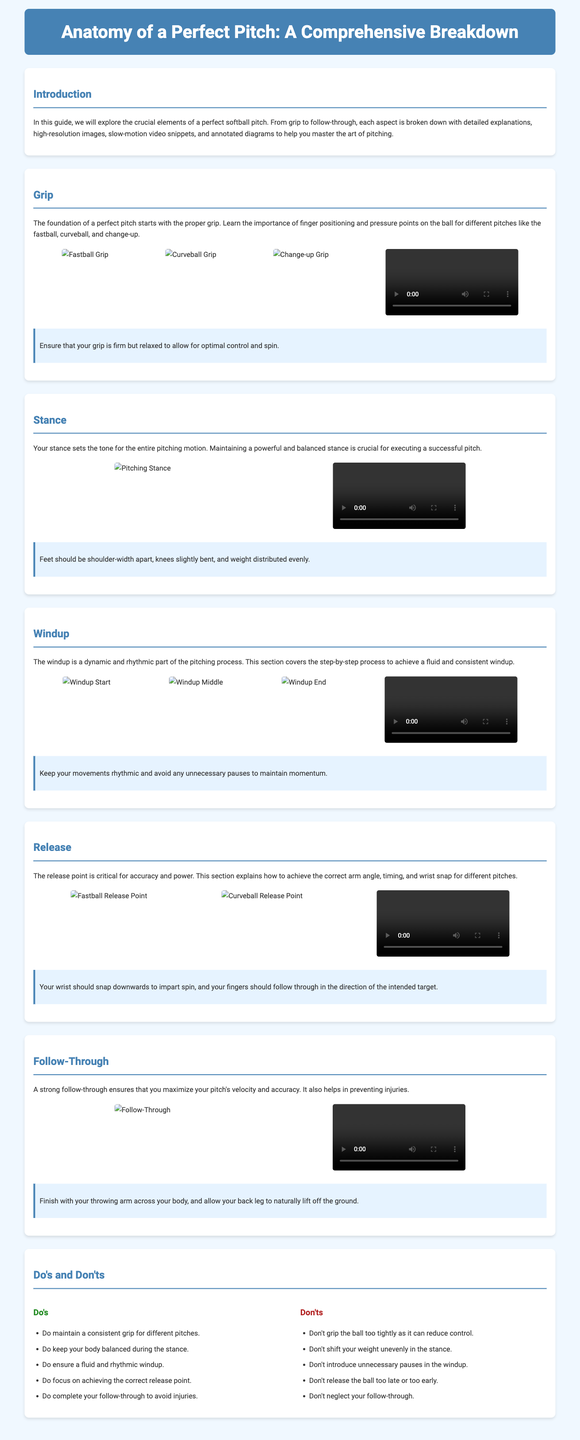What is the title of the guide? The title is stated in the header of the document and introduces the subject of the content.
Answer: Anatomy of a Perfect Pitch: A Comprehensive Breakdown What section covers the importance of grip? The grip is discussed in its own dedicated section that elaborates on the mechanics involved.
Answer: Grip How many key elements are highlighted in the Do's section? The Do's section lists a specific number of recommended practices for pitching.
Answer: Five What angle is emphasized at the release point? The release section discusses the significance of a particular angle related to arm positioning during pitching.
Answer: Correct arm angle In which section is the follow-through discussed? The follow-through is detailed in its own section focusing on completing the pitching motion.
Answer: Follow-Through What do you need to maintain during the windup? The windup section emphasizes the necessity of a particular quality during the pitching motion.
Answer: Rhythmic movements How should you distribute your weight in the stance? The stance section provides guidance on how to balance your body weight while pitching.
Answer: Evenly Which video type accompanies the grip section? The document includes specific types of media to provide visual aid in understanding the grip.
Answer: Slow-motion video What color is used for the section titles? The section titles are presented in a specific color that differentiates them from the rest of the text.
Answer: #4682b4 